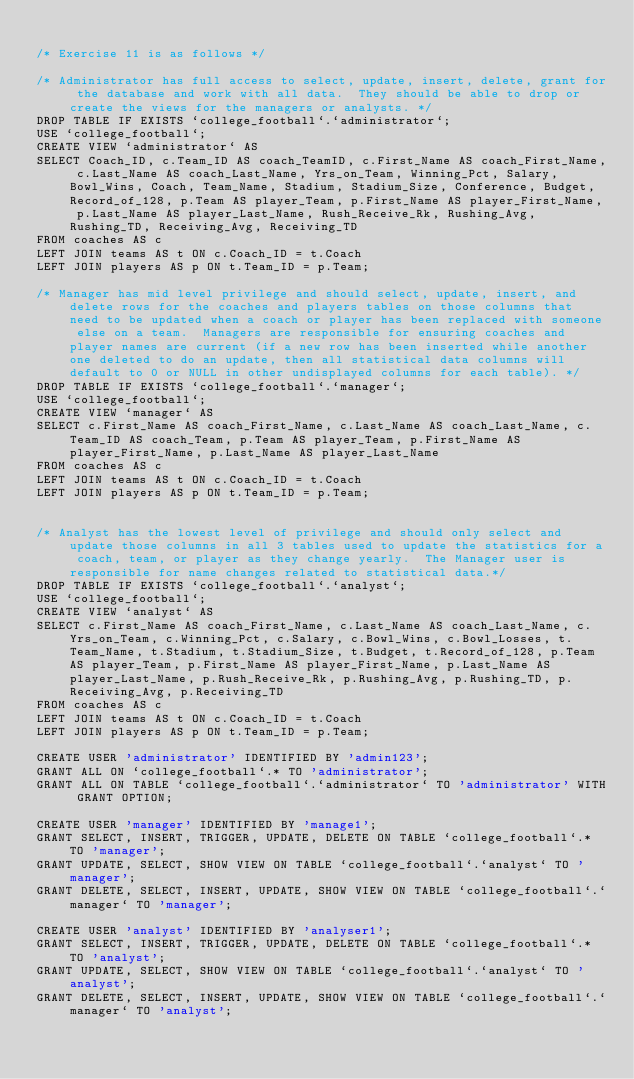<code> <loc_0><loc_0><loc_500><loc_500><_SQL_>
/* Exercise 11 is as follows */

/* Administrator has full access to select, update, insert, delete, grant for the database and work with all data.  They should be able to drop or create the views for the managers or analysts. */
DROP TABLE IF EXISTS `college_football`.`administrator`;
USE `college_football`;
CREATE VIEW `administrator` AS
SELECT Coach_ID, c.Team_ID AS coach_TeamID, c.First_Name AS coach_First_Name, c.Last_Name AS coach_Last_Name, Yrs_on_Team, Winning_Pct, Salary, Bowl_Wins, Coach, Team_Name, Stadium, Stadium_Size, Conference, Budget, Record_of_128, p.Team AS player_Team, p.First_Name AS player_First_Name, p.Last_Name AS player_Last_Name, Rush_Receive_Rk, Rushing_Avg, Rushing_TD, Receiving_Avg, Receiving_TD
FROM coaches AS c
LEFT JOIN teams AS t ON c.Coach_ID = t.Coach
LEFT JOIN players AS p ON t.Team_ID = p.Team; 

/* Manager has mid level privilege and should select, update, insert, and delete rows for the coaches and players tables on those columns that need to be updated when a coach or player has been replaced with someone else on a team.  Managers are responsible for ensuring coaches and player names are current (if a new row has been inserted while another one deleted to do an update, then all statistical data columns will default to 0 or NULL in other undisplayed columns for each table). */
DROP TABLE IF EXISTS `college_football`.`manager`;
USE `college_football`;
CREATE VIEW `manager` AS
SELECT c.First_Name AS coach_First_Name, c.Last_Name AS coach_Last_Name, c.Team_ID AS coach_Team, p.Team AS player_Team, p.First_Name AS player_First_Name, p.Last_Name AS player_Last_Name
FROM coaches AS c
LEFT JOIN teams AS t ON c.Coach_ID = t.Coach
LEFT JOIN players AS p ON t.Team_ID = p.Team; 


/* Analyst has the lowest level of privilege and should only select and update those columns in all 3 tables used to update the statistics for a coach, team, or player as they change yearly.  The Manager user is responsible for name changes related to statistical data.*/
DROP TABLE IF EXISTS `college_football`.`analyst`;
USE `college_football`;
CREATE VIEW `analyst` AS
SELECT c.First_Name AS coach_First_Name, c.Last_Name AS coach_Last_Name, c.Yrs_on_Team, c.Winning_Pct, c.Salary, c.Bowl_Wins, c.Bowl_Losses, t.Team_Name, t.Stadium, t.Stadium_Size, t.Budget, t.Record_of_128, p.Team AS player_Team, p.First_Name AS player_First_Name, p.Last_Name AS player_Last_Name, p.Rush_Receive_Rk, p.Rushing_Avg, p.Rushing_TD, p.Receiving_Avg, p.Receiving_TD 
FROM coaches AS c
LEFT JOIN teams AS t ON c.Coach_ID = t.Coach
LEFT JOIN players AS p ON t.Team_ID = p.Team;

CREATE USER 'administrator' IDENTIFIED BY 'admin123';
GRANT ALL ON `college_football`.* TO 'administrator';
GRANT ALL ON TABLE `college_football`.`administrator` TO 'administrator' WITH GRANT OPTION;

CREATE USER 'manager' IDENTIFIED BY 'manage1';
GRANT SELECT, INSERT, TRIGGER, UPDATE, DELETE ON TABLE `college_football`.* TO 'manager';
GRANT UPDATE, SELECT, SHOW VIEW ON TABLE `college_football`.`analyst` TO 'manager';
GRANT DELETE, SELECT, INSERT, UPDATE, SHOW VIEW ON TABLE `college_football`.`manager` TO 'manager';

CREATE USER 'analyst' IDENTIFIED BY 'analyser1';
GRANT SELECT, INSERT, TRIGGER, UPDATE, DELETE ON TABLE `college_football`.* TO 'analyst';
GRANT UPDATE, SELECT, SHOW VIEW ON TABLE `college_football`.`analyst` TO 'analyst';
GRANT DELETE, SELECT, INSERT, UPDATE, SHOW VIEW ON TABLE `college_football`.`manager` TO 'analyst';</code> 